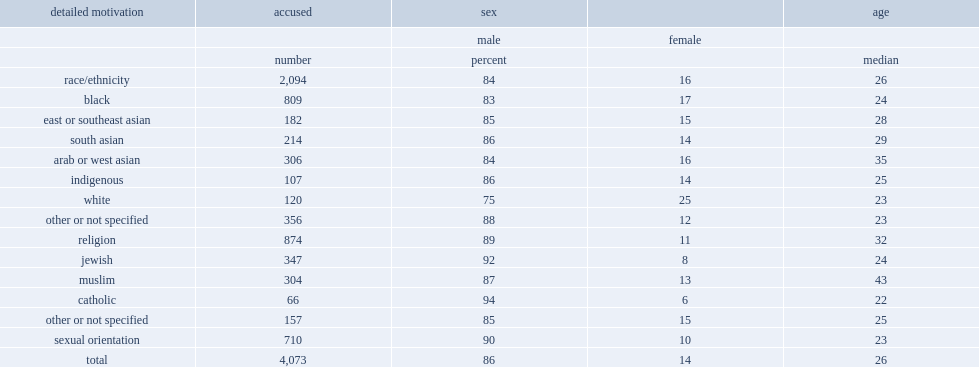Overall, from 2010 to 2018, what the percentage of persons accused of hate crime targeting race/ethnicity were male? 84.0. Overall, from 2010 to 2018, what the percentage of persons accused of hate crime targeting religion were male? 89.0. Overall, from 2010 to 2018, what the percentage of persons accused of hate crime targeting sexual orientation were male? 90.0. What was the median age for persons accused of hate crime? 26.0. 